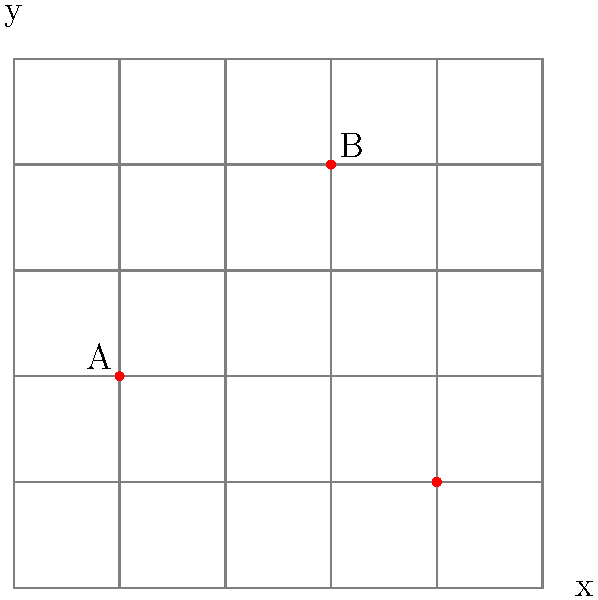Your new puppy loves to play in the backyard! You've noticed three favorite spots where the puppy likes to play. On the grid, these spots are marked as A, B, and C. Can you tell what the coordinates of spot B are? Let's figure this out step-by-step:

1. First, we need to understand how to read coordinates. The first number is the x-coordinate (how far right), and the second number is the y-coordinate (how far up).

2. We're asked about spot B, so let's focus on that point.

3. To find the x-coordinate of B, we count how many squares to the right it is from the origin (0,0). We can see it's 3 squares to the right.

4. For the y-coordinate, we count how many squares up it is from the origin. We can see it's 4 squares up.

5. Therefore, the coordinates of spot B are $(3,4)$.

Remember, we always write coordinates as (x,y), with x first and y second, inside parentheses.
Answer: $(3,4)$ 